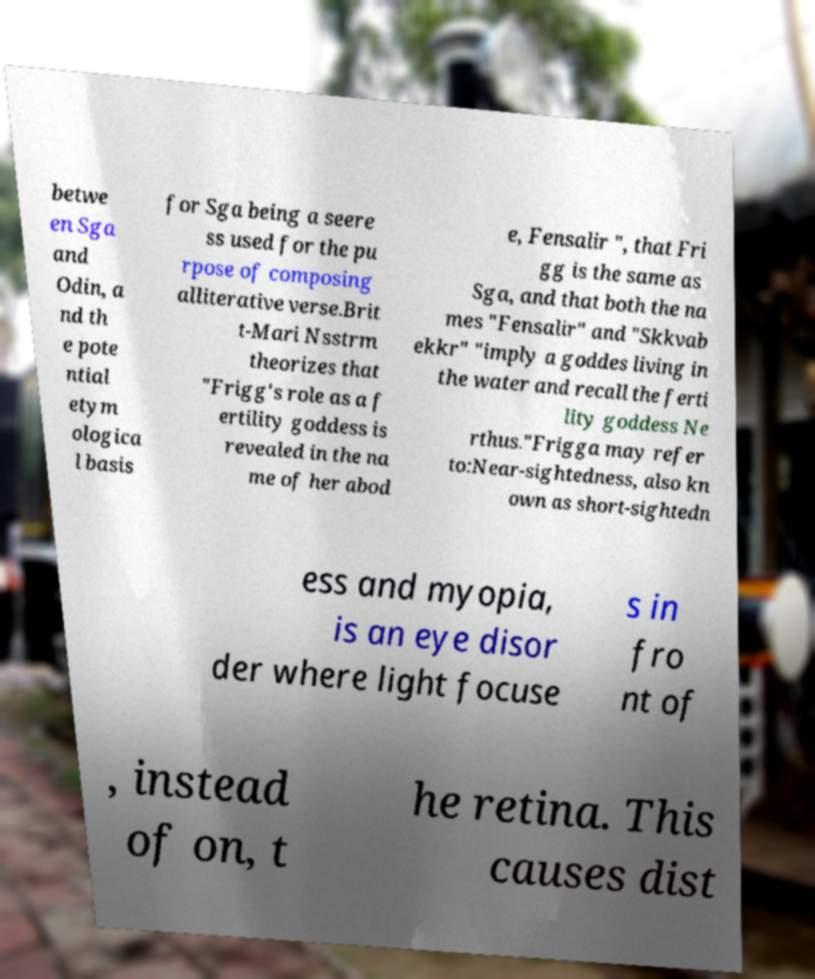What messages or text are displayed in this image? I need them in a readable, typed format. betwe en Sga and Odin, a nd th e pote ntial etym ologica l basis for Sga being a seere ss used for the pu rpose of composing alliterative verse.Brit t-Mari Nsstrm theorizes that "Frigg's role as a f ertility goddess is revealed in the na me of her abod e, Fensalir ", that Fri gg is the same as Sga, and that both the na mes "Fensalir" and "Skkvab ekkr" "imply a goddes living in the water and recall the ferti lity goddess Ne rthus."Frigga may refer to:Near-sightedness, also kn own as short-sightedn ess and myopia, is an eye disor der where light focuse s in fro nt of , instead of on, t he retina. This causes dist 